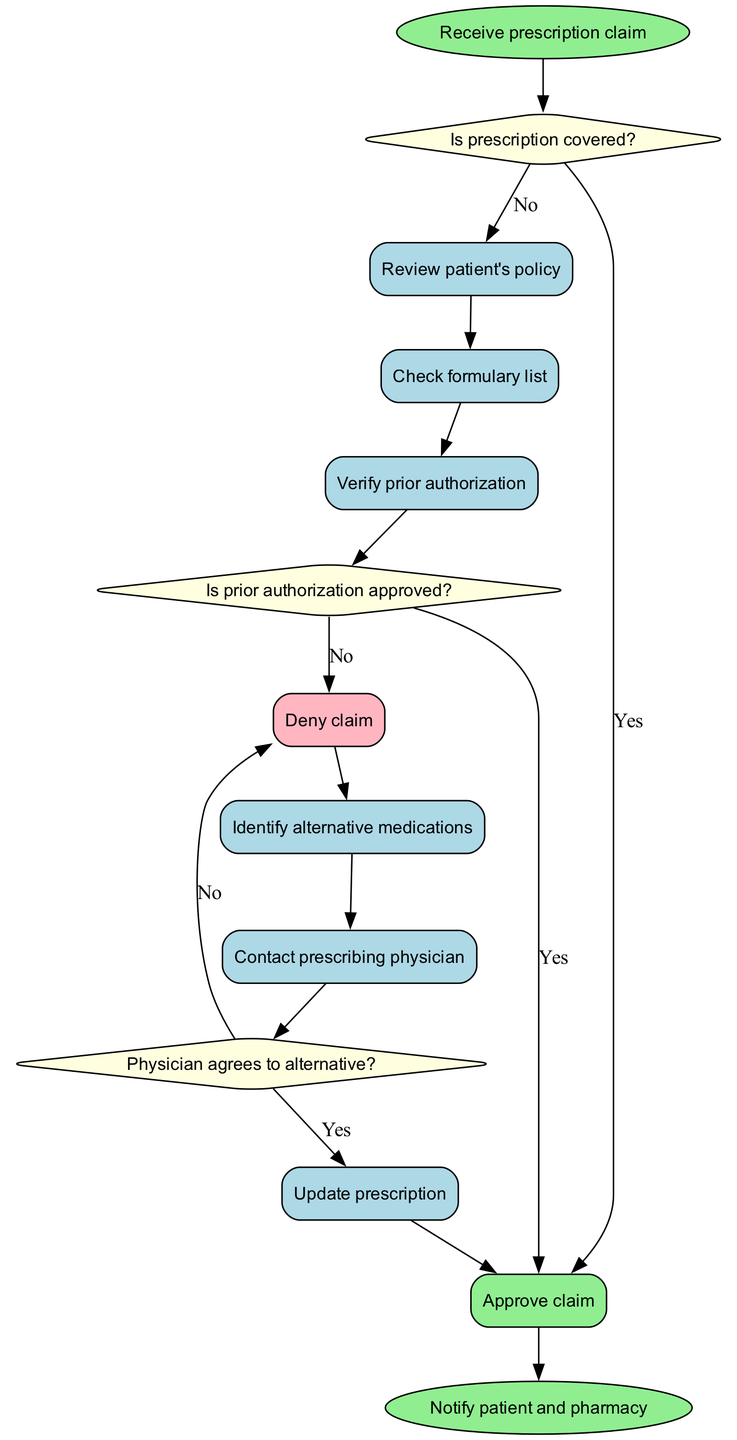What is the first step in the workflow? The first step, indicated by the starting node, is "Receive prescription claim". Thus, the workflow begins with this initial action.
Answer: Receive prescription claim How many decision nodes are present in the workflow? The diagram contains three decision nodes: "Is prescription covered?", "Is prior authorization approved?", and "Physician agrees to alternative?". Therefore, the total is three.
Answer: 3 What happens if the prescription is covered? If the prescription is covered, the flow moves directly to the node "Approve claim". This means that the claim gets approved without further review.
Answer: Approve claim What is the outcome if prior authorization is not approved? If the prior authorization is not approved, the flow leads to the process "Deny claim". This indicates that the claim will be denied if authorization is not granted.
Answer: Deny claim Which process follows the decision node about the physician's agreement? The process that follows the decision node "Physician agrees to alternative?" when the answer is "Yes" is "Update prescription", indicating a change to the initial prescription according to the new alternatives.
Answer: Update prescription What process comes before contacting the prescribing physician? Before contacting the prescribing physician, the workflow requires identifying alternative medications, which is the process that leads to this action.
Answer: Identify alternative medications If the prescription is denied, how does the workflow proceed? If the prescription is denied, it proceeds from the "Deny claim" process to the "Identify alternative medications" process, indicating actions taken to find other acceptable medications for the patient.
Answer: Identify alternative medications What is the final step in the claims processing workflow? The final step in the workflow is the notification to both the patient and the pharmacy, as indicated by the end node. This signifies the conclusion of the claims processing.
Answer: Notify patient and pharmacy 